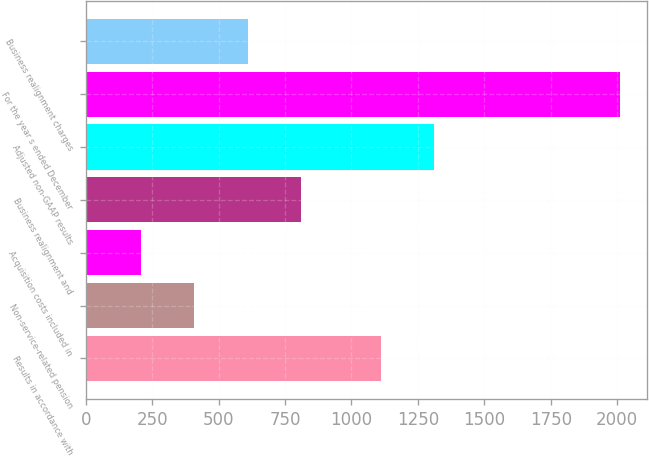Convert chart. <chart><loc_0><loc_0><loc_500><loc_500><bar_chart><fcel>Results in accordance with<fcel>Non-service-related pension<fcel>Acquisition costs included in<fcel>Business realignment and<fcel>Adjusted non-GAAP results<fcel>For the year s ended December<fcel>Business realignment charges<nl><fcel>1111.1<fcel>408.88<fcel>208.74<fcel>809.16<fcel>1311.24<fcel>2010<fcel>609.02<nl></chart> 